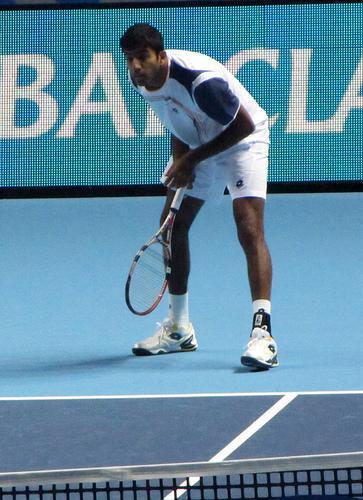How many people are in the picture?
Give a very brief answer. 1. 